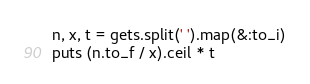Convert code to text. <code><loc_0><loc_0><loc_500><loc_500><_Ruby_>n, x, t = gets.split(' ').map(&:to_i)
puts (n.to_f / x).ceil * t</code> 